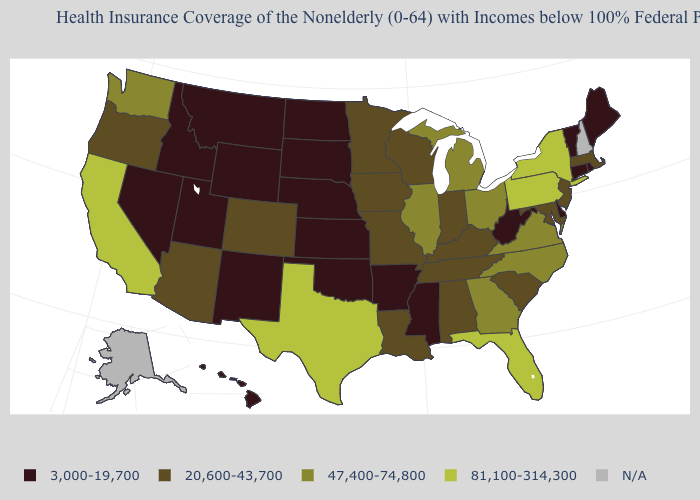What is the value of West Virginia?
Concise answer only. 3,000-19,700. Name the states that have a value in the range 20,600-43,700?
Keep it brief. Alabama, Arizona, Colorado, Indiana, Iowa, Kentucky, Louisiana, Maryland, Massachusetts, Minnesota, Missouri, New Jersey, Oregon, South Carolina, Tennessee, Wisconsin. Name the states that have a value in the range 20,600-43,700?
Write a very short answer. Alabama, Arizona, Colorado, Indiana, Iowa, Kentucky, Louisiana, Maryland, Massachusetts, Minnesota, Missouri, New Jersey, Oregon, South Carolina, Tennessee, Wisconsin. What is the lowest value in the West?
Write a very short answer. 3,000-19,700. Which states have the highest value in the USA?
Be succinct. California, Florida, New York, Pennsylvania, Texas. Does Mississippi have the lowest value in the South?
Short answer required. Yes. Which states have the lowest value in the USA?
Quick response, please. Arkansas, Connecticut, Delaware, Hawaii, Idaho, Kansas, Maine, Mississippi, Montana, Nebraska, Nevada, New Mexico, North Dakota, Oklahoma, Rhode Island, South Dakota, Utah, Vermont, West Virginia, Wyoming. How many symbols are there in the legend?
Give a very brief answer. 5. Among the states that border Arizona , does Utah have the lowest value?
Write a very short answer. Yes. What is the value of Hawaii?
Short answer required. 3,000-19,700. What is the value of Vermont?
Short answer required. 3,000-19,700. What is the value of Oklahoma?
Quick response, please. 3,000-19,700. Is the legend a continuous bar?
Keep it brief. No. Does the map have missing data?
Write a very short answer. Yes. 